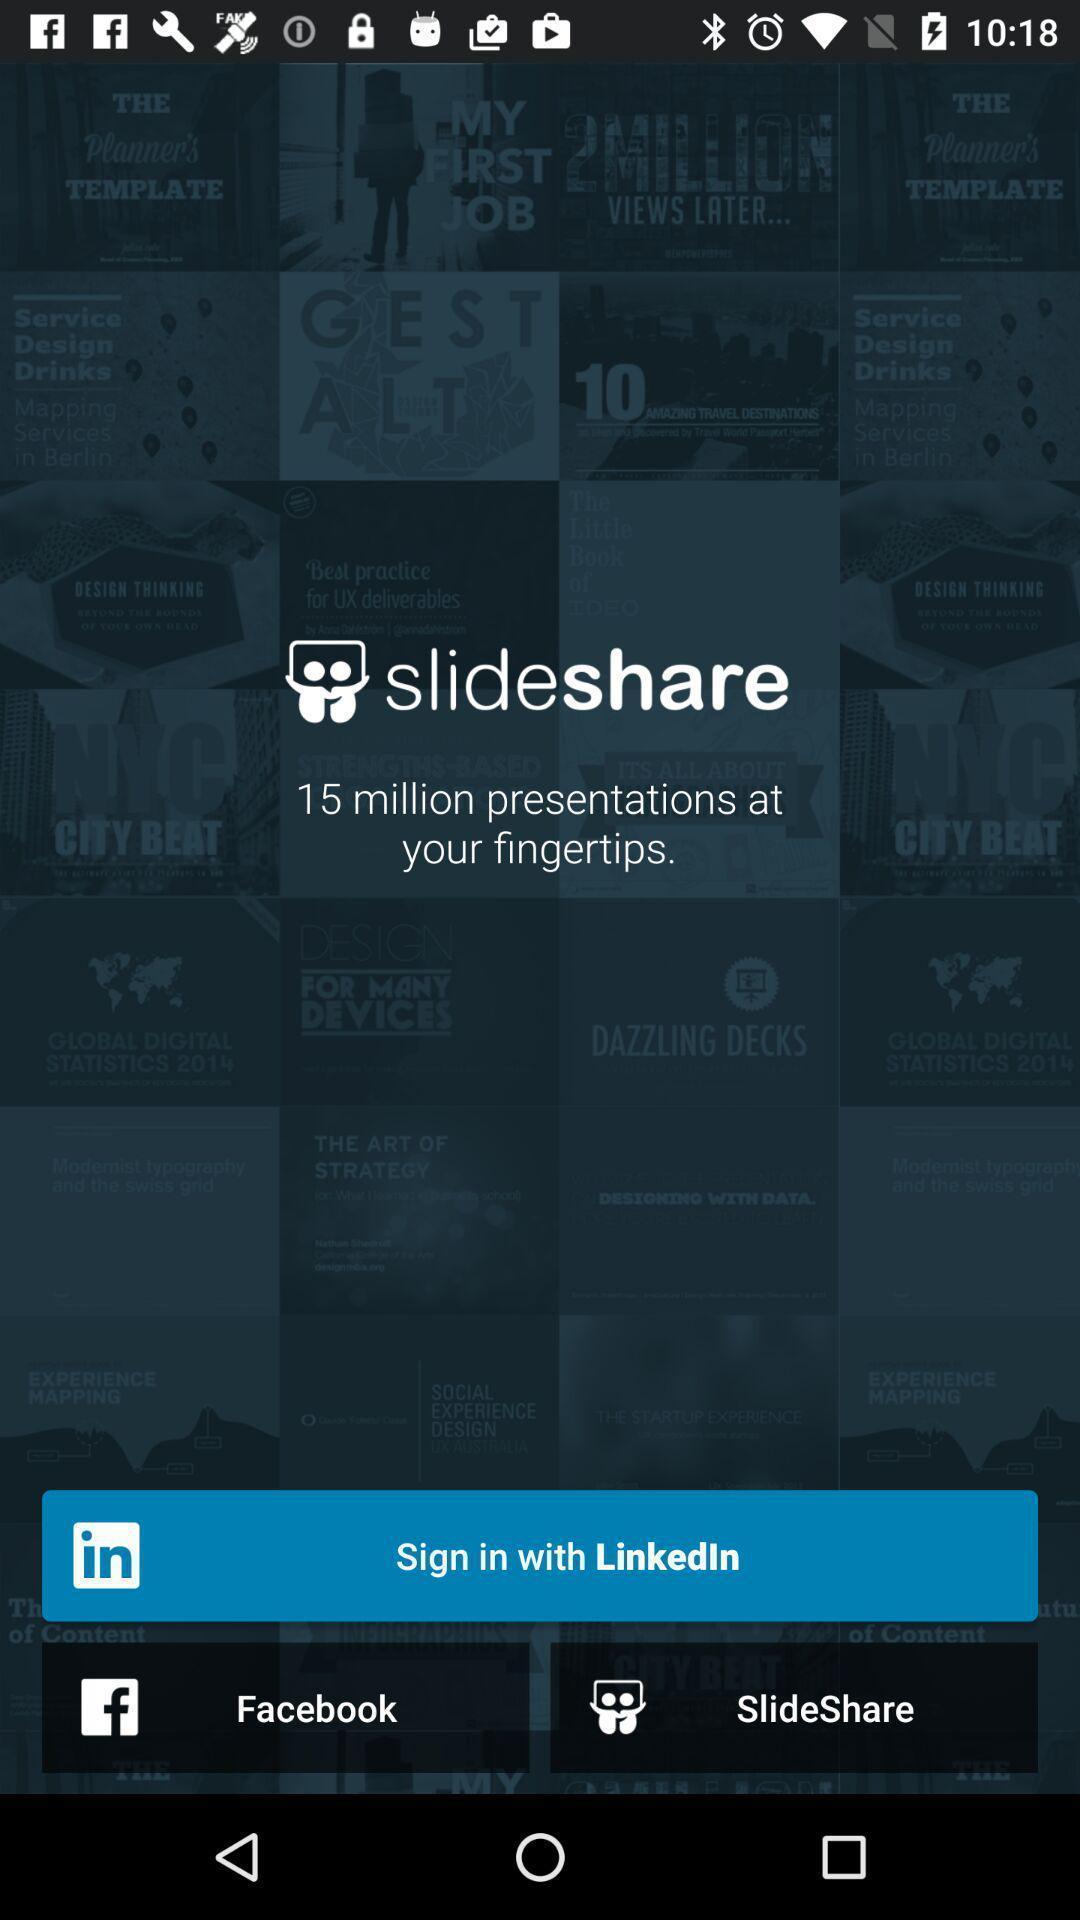Provide a textual representation of this image. Welcome page showing various sign in options. 